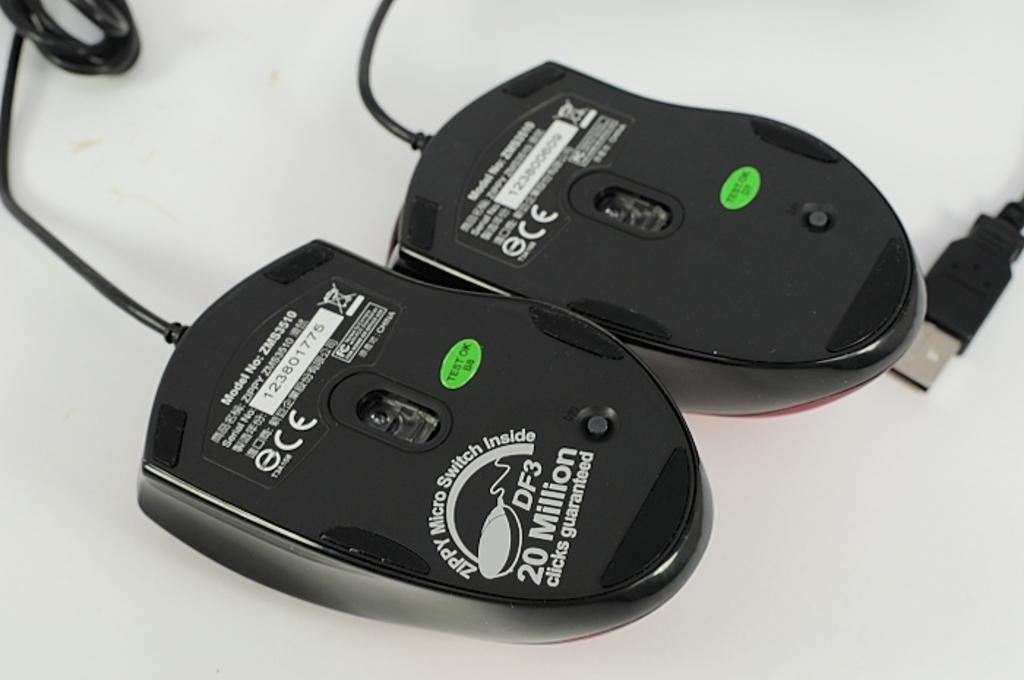<image>
Create a compact narrative representing the image presented. Durable computer mouse with 20 million clicks guaranteed. 